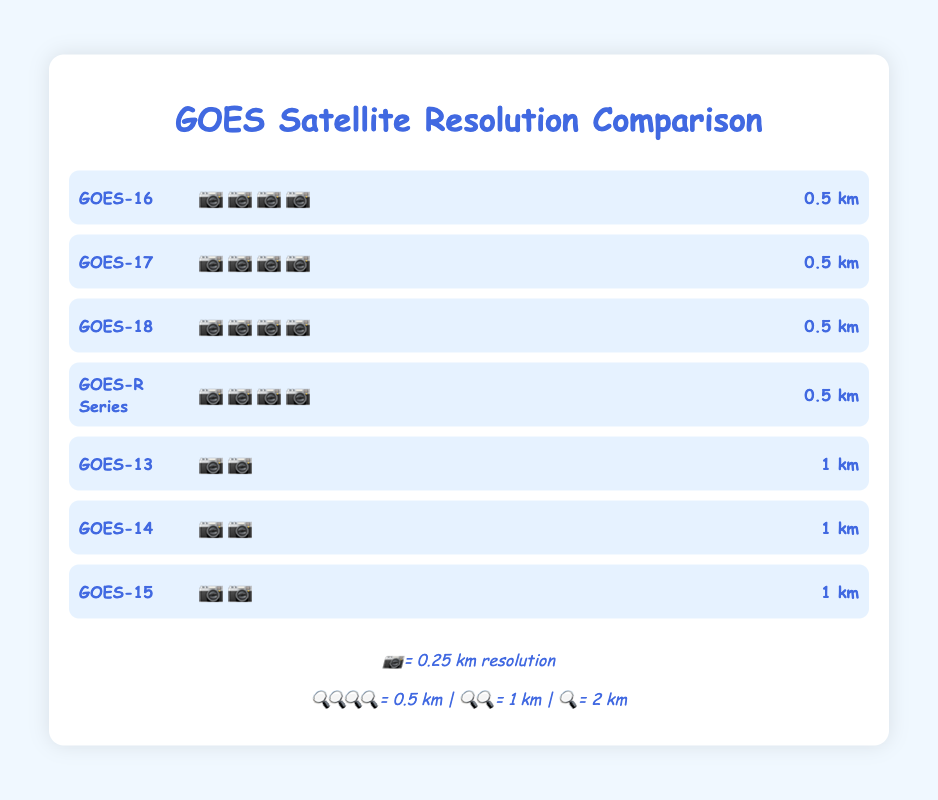What's the title of the chart? The title of the chart is written at the top in large, colored text, and it reads "GOES Satellite Resolution Comparison."
Answer: GOES Satellite Resolution Comparison What is the resolution of GOES-16? To find the resolution of GOES-16, look at the bar labeled "GOES-16," and at the end of the bar, there is a text indicating the resolution as "0.5 km."
Answer: 0.5 km Which satellites have the best resolution? The best resolution in the chart is 0.5 km, and the satellites that have this resolution include GOES-16, GOES-17, GOES-18, and the GOES-R Series. This can be determined from the bars showing "0.5 km" next to these satellites.
Answer: GOES-16, GOES-17, GOES-18, GOES-R Series How does the resolution of GOES-14 compare to GOES-17? GOES-14 has a resolution of 1 km, while GOES-17 has a resolution of 0.5 km. This comparison can be made by looking at the end of each bar for these satellites.
Answer: GOES-14 has a lower resolution than GOES-17 What is the average resolution of GOES-13, GOES-14, and GOES-15? GOES-13, GOES-14, and GOES-15 each have a resolution of 1 km. To find the average, add their resolutions (1 + 1 + 1) and divide by 3. The average is (1 + 1 + 1) / 3 = 1 km.
Answer: 1 km Which satellite series has all of its satellites with a 0.5 km resolution? The GOES-R series is mentioned in the chart, and its bar shows a resolution of 0.5 km. Therefore, the entire GOES-R series has a 0.5 km resolution.
Answer: GOES-R Series How many different resolution values are represented in the chart? There are resolution values of 0.5 km and 1 km represented in the chart, as indicated in the bars and the legend. Hence, there are 2 different resolution values.
Answer: 2 If a new satellite with a 0.25 km resolution is introduced, how many camera emojis would it have? According to the legend, each camera emoji represents 0.25 km resolution. Therefore, a satellite with a 0.25 km resolution would have one camera emoji.
Answer: 📷 What is the sum of the resolutions for all satellites shown? Summing up the resolutions for all satellites gives us: 0.5 (GOES-16) + 0.5 (GOES-17) + 0.5 (GOES-18) + 0.5 (GOES-R Series) + 1 (GOES-13) + 1 (GOES-14) + 1 (GOES-15) = 5 km.
Answer: 5 km What do the different camera emojis represent in the chart? In the chart, camera emojis represent the satellite resolutions, with each camera emoji equivalent to 0.25 km resolution. More cameras indicate better (higher) resolution.
Answer: Resolution indicator 